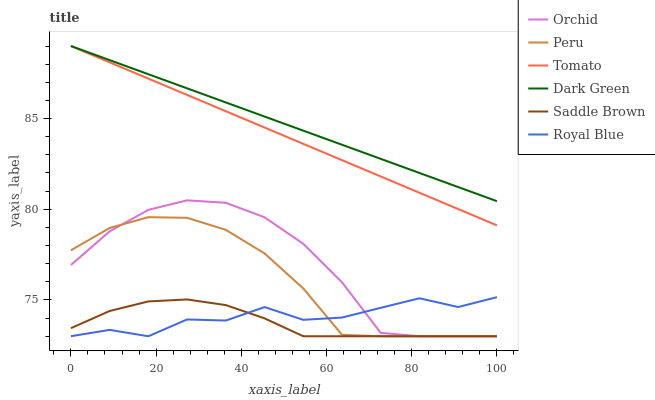Does Saddle Brown have the minimum area under the curve?
Answer yes or no. Yes. Does Dark Green have the maximum area under the curve?
Answer yes or no. Yes. Does Royal Blue have the minimum area under the curve?
Answer yes or no. No. Does Royal Blue have the maximum area under the curve?
Answer yes or no. No. Is Dark Green the smoothest?
Answer yes or no. Yes. Is Royal Blue the roughest?
Answer yes or no. Yes. Is Peru the smoothest?
Answer yes or no. No. Is Peru the roughest?
Answer yes or no. No. Does Royal Blue have the lowest value?
Answer yes or no. Yes. Does Dark Green have the lowest value?
Answer yes or no. No. Does Dark Green have the highest value?
Answer yes or no. Yes. Does Royal Blue have the highest value?
Answer yes or no. No. Is Saddle Brown less than Tomato?
Answer yes or no. Yes. Is Tomato greater than Peru?
Answer yes or no. Yes. Does Royal Blue intersect Orchid?
Answer yes or no. Yes. Is Royal Blue less than Orchid?
Answer yes or no. No. Is Royal Blue greater than Orchid?
Answer yes or no. No. Does Saddle Brown intersect Tomato?
Answer yes or no. No. 